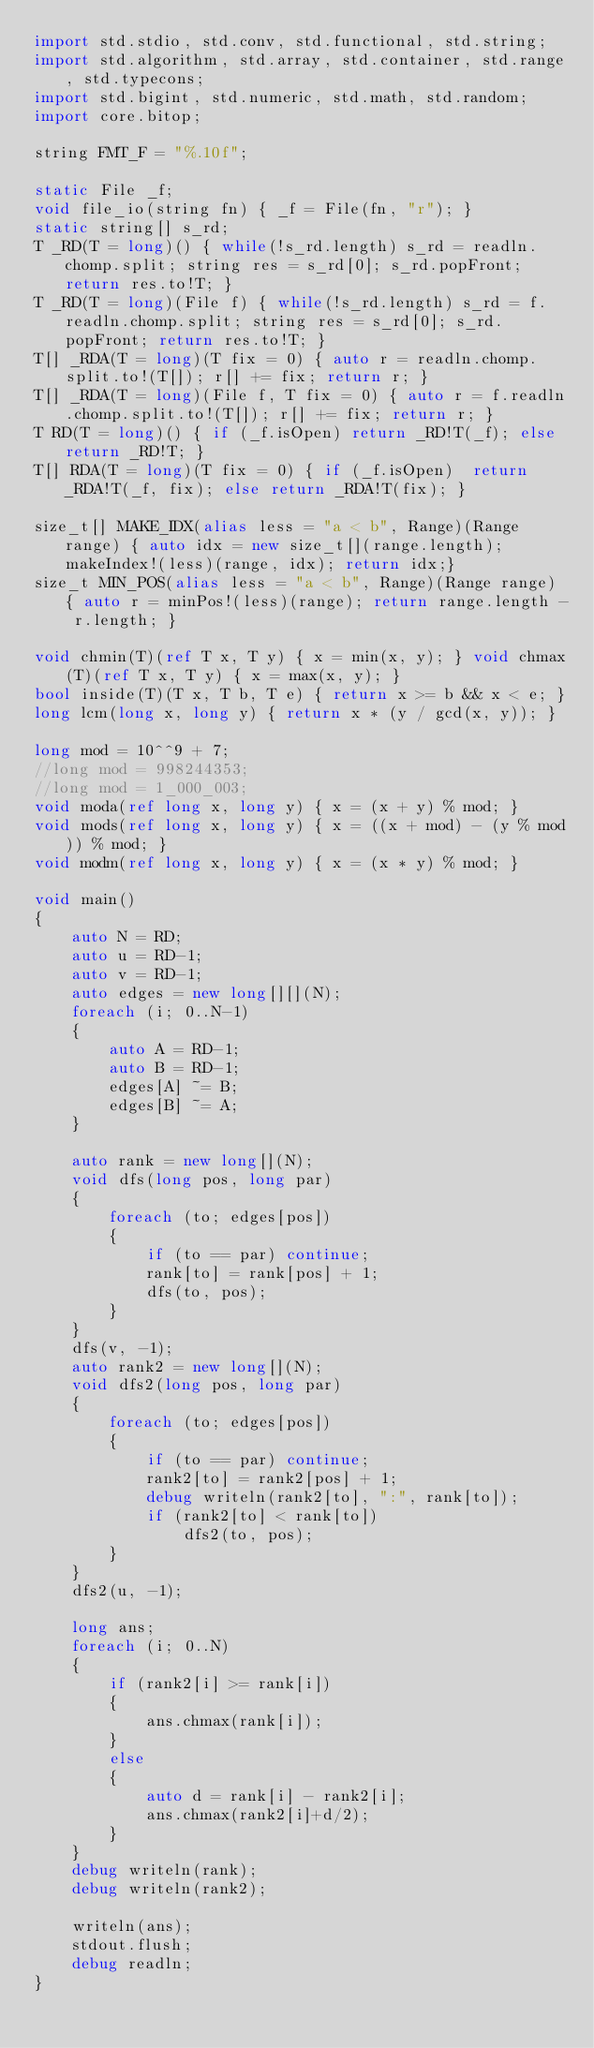Convert code to text. <code><loc_0><loc_0><loc_500><loc_500><_D_>import std.stdio, std.conv, std.functional, std.string;
import std.algorithm, std.array, std.container, std.range, std.typecons;
import std.bigint, std.numeric, std.math, std.random;
import core.bitop;

string FMT_F = "%.10f";

static File _f;
void file_io(string fn) { _f = File(fn, "r"); }
static string[] s_rd;
T _RD(T = long)() { while(!s_rd.length) s_rd = readln.chomp.split; string res = s_rd[0]; s_rd.popFront; return res.to!T; }
T _RD(T = long)(File f) { while(!s_rd.length) s_rd = f.readln.chomp.split; string res = s_rd[0]; s_rd.popFront; return res.to!T; }
T[] _RDA(T = long)(T fix = 0) { auto r = readln.chomp.split.to!(T[]); r[] += fix; return r; }
T[] _RDA(T = long)(File f, T fix = 0) { auto r = f.readln.chomp.split.to!(T[]); r[] += fix; return r; }
T RD(T = long)() { if (_f.isOpen) return _RD!T(_f); else return _RD!T; }
T[] RDA(T = long)(T fix = 0) { if (_f.isOpen)  return _RDA!T(_f, fix); else return _RDA!T(fix); }

size_t[] MAKE_IDX(alias less = "a < b", Range)(Range range) { auto idx = new size_t[](range.length); makeIndex!(less)(range, idx); return idx;}
size_t MIN_POS(alias less = "a < b", Range)(Range range) { auto r = minPos!(less)(range); return range.length - r.length; }

void chmin(T)(ref T x, T y) { x = min(x, y); } void chmax(T)(ref T x, T y) { x = max(x, y); }
bool inside(T)(T x, T b, T e) { return x >= b && x < e; }
long lcm(long x, long y) { return x * (y / gcd(x, y)); }

long mod = 10^^9 + 7;
//long mod = 998244353;
//long mod = 1_000_003;
void moda(ref long x, long y) { x = (x + y) % mod; }
void mods(ref long x, long y) { x = ((x + mod) - (y % mod)) % mod; }
void modm(ref long x, long y) { x = (x * y) % mod; }

void main()
{
	auto N = RD;
	auto u = RD-1;
	auto v = RD-1;
	auto edges = new long[][](N);
	foreach (i; 0..N-1)
	{
		auto A = RD-1;
		auto B = RD-1;
		edges[A] ~= B;
		edges[B] ~= A;
	}

	auto rank = new long[](N);
	void dfs(long pos, long par)
	{
		foreach (to; edges[pos])
		{
			if (to == par) continue;
			rank[to] = rank[pos] + 1;
			dfs(to, pos);
		}
	}
	dfs(v, -1);
	auto rank2 = new long[](N);
	void dfs2(long pos, long par)
	{
		foreach (to; edges[pos])
		{
			if (to == par) continue;
			rank2[to] = rank2[pos] + 1;
			debug writeln(rank2[to], ":", rank[to]);
			if (rank2[to] < rank[to])
				dfs2(to, pos);
		}
	}
	dfs2(u, -1);
	
	long ans;
	foreach (i; 0..N)
	{
		if (rank2[i] >= rank[i])
		{
			ans.chmax(rank[i]);
		}
		else
		{
			auto d = rank[i] - rank2[i];
			ans.chmax(rank2[i]+d/2);
		}
	}
	debug writeln(rank);
	debug writeln(rank2);

	writeln(ans);
	stdout.flush;
	debug readln;
}</code> 